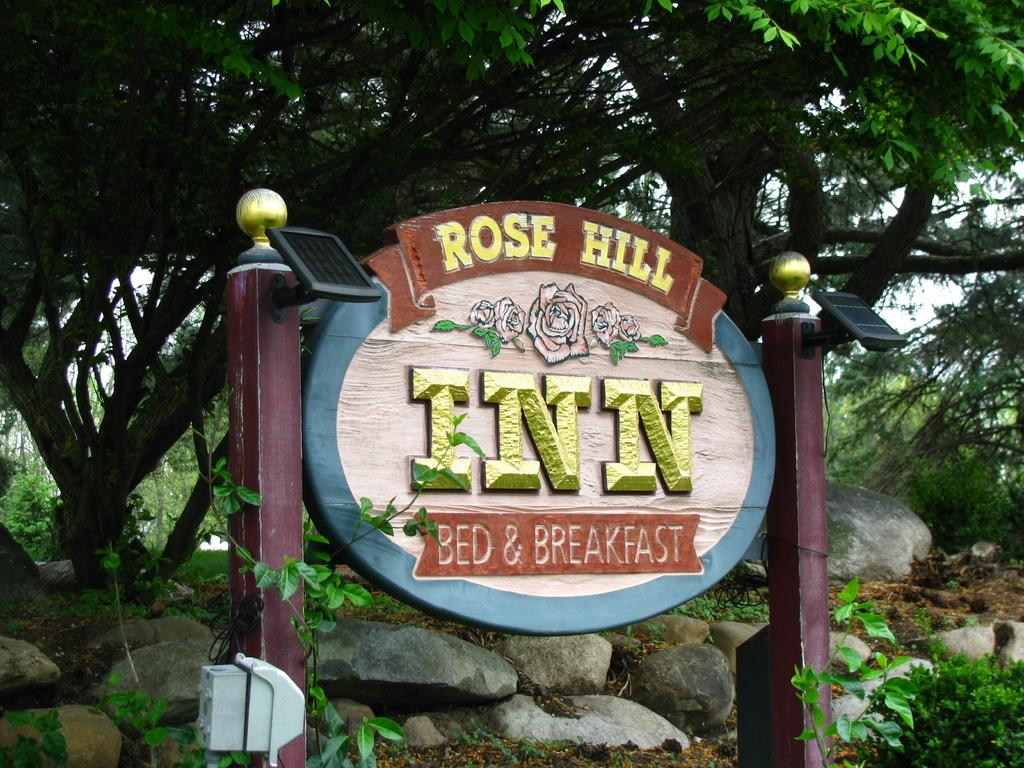What is the main structure in the image? There is a board with lights attached to pillars in the image. What is located in front of the board? There is a white object in front of the board. What can be seen in the background of the image? Rocks and trees are present in the background of the image. Where is the honey stored in the image? There is no honey present in the image. What type of locket is hanging from the tree in the background? There is no locket present in the image; only rocks and trees are visible in the background. 